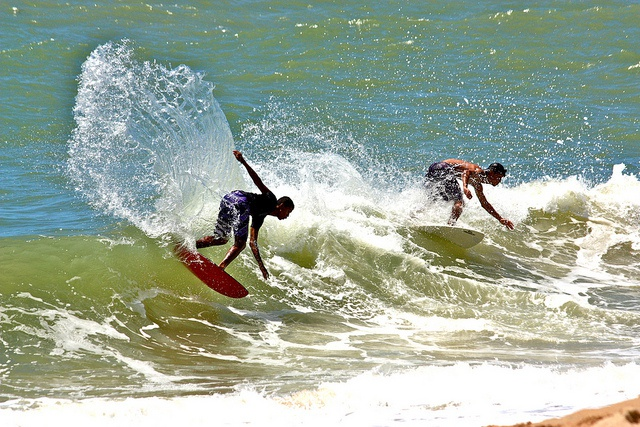Describe the objects in this image and their specific colors. I can see people in gray, black, white, and darkgray tones, people in gray, black, maroon, and darkgray tones, surfboard in gray, maroon, and olive tones, and surfboard in gray and olive tones in this image. 